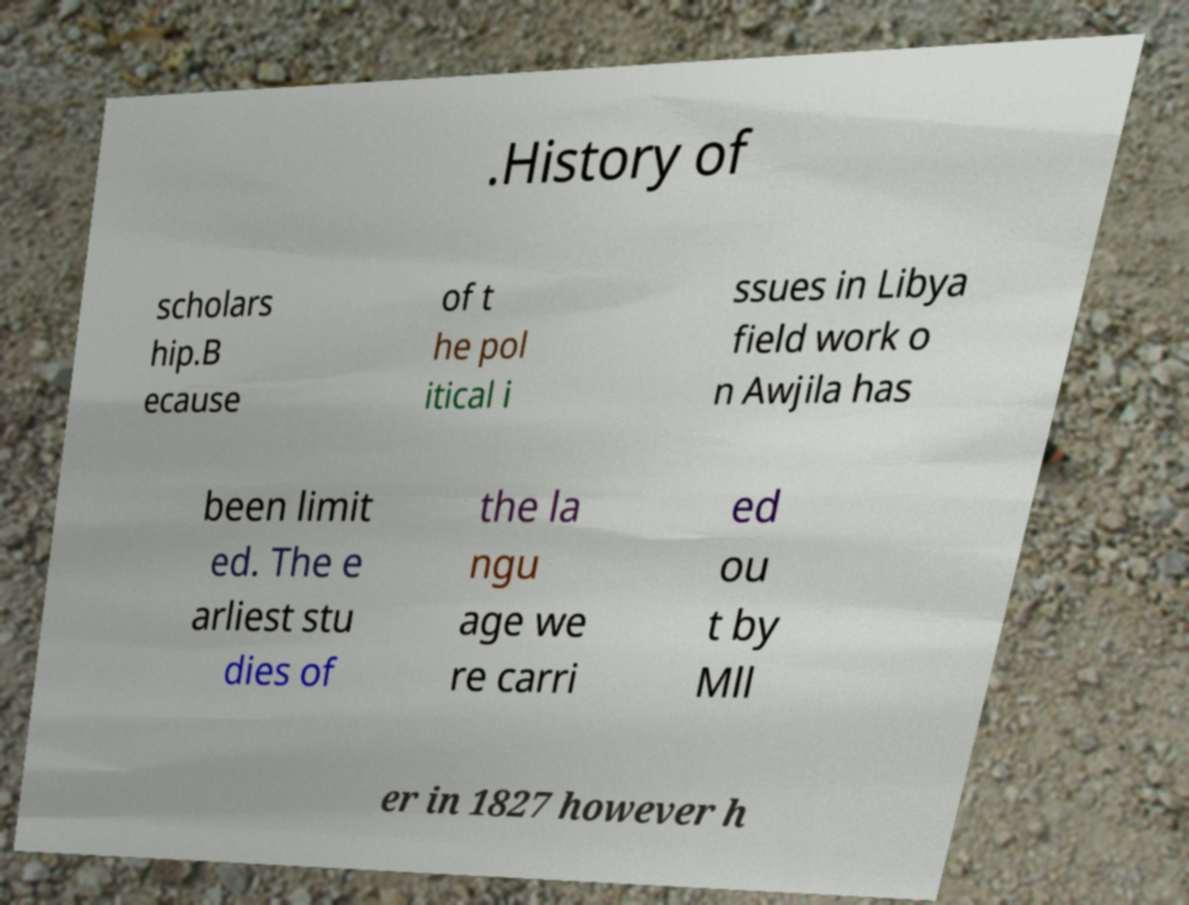Could you assist in decoding the text presented in this image and type it out clearly? .History of scholars hip.B ecause of t he pol itical i ssues in Libya field work o n Awjila has been limit ed. The e arliest stu dies of the la ngu age we re carri ed ou t by Mll er in 1827 however h 